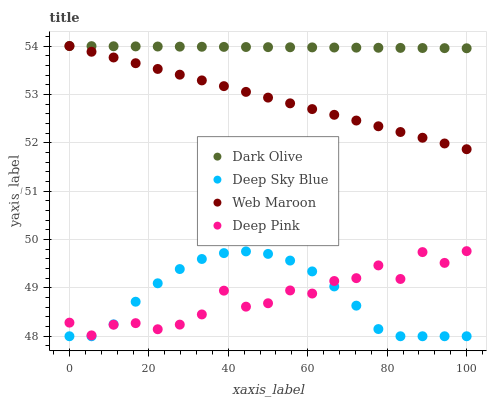Does Deep Pink have the minimum area under the curve?
Answer yes or no. Yes. Does Dark Olive have the maximum area under the curve?
Answer yes or no. Yes. Does Web Maroon have the minimum area under the curve?
Answer yes or no. No. Does Web Maroon have the maximum area under the curve?
Answer yes or no. No. Is Web Maroon the smoothest?
Answer yes or no. Yes. Is Deep Pink the roughest?
Answer yes or no. Yes. Is Deep Sky Blue the smoothest?
Answer yes or no. No. Is Deep Sky Blue the roughest?
Answer yes or no. No. Does Deep Sky Blue have the lowest value?
Answer yes or no. Yes. Does Web Maroon have the lowest value?
Answer yes or no. No. Does Web Maroon have the highest value?
Answer yes or no. Yes. Does Deep Sky Blue have the highest value?
Answer yes or no. No. Is Deep Sky Blue less than Web Maroon?
Answer yes or no. Yes. Is Dark Olive greater than Deep Pink?
Answer yes or no. Yes. Does Deep Sky Blue intersect Deep Pink?
Answer yes or no. Yes. Is Deep Sky Blue less than Deep Pink?
Answer yes or no. No. Is Deep Sky Blue greater than Deep Pink?
Answer yes or no. No. Does Deep Sky Blue intersect Web Maroon?
Answer yes or no. No. 